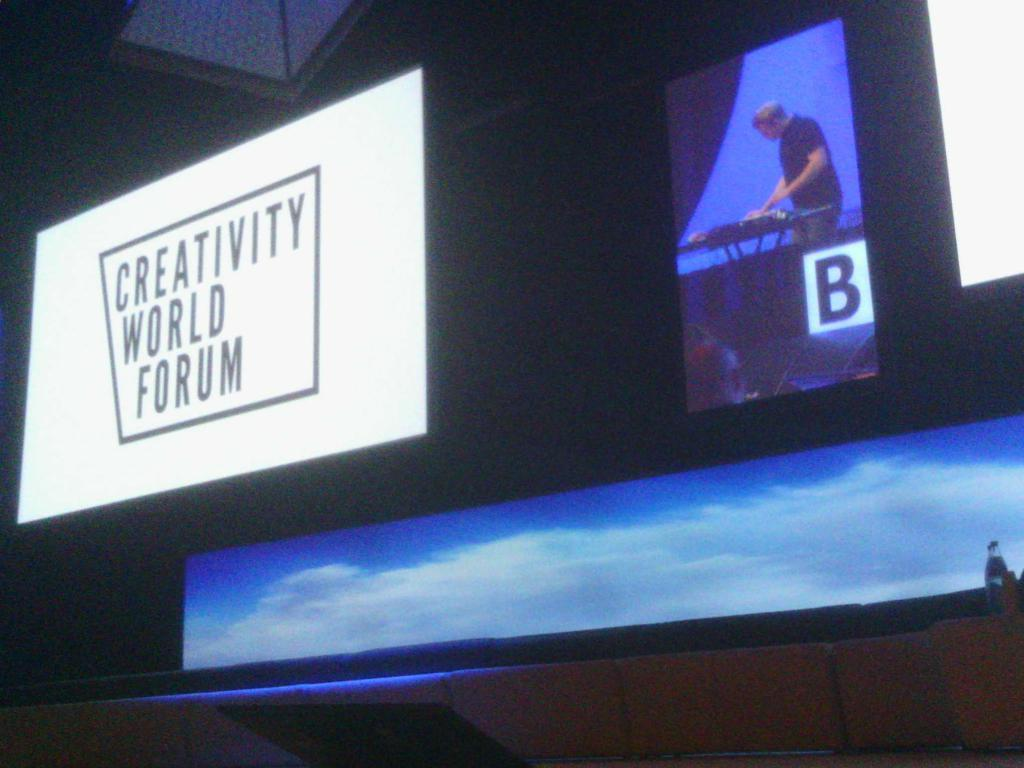<image>
Render a clear and concise summary of the photo. A screen with "Creativity World Forum" written on it. 